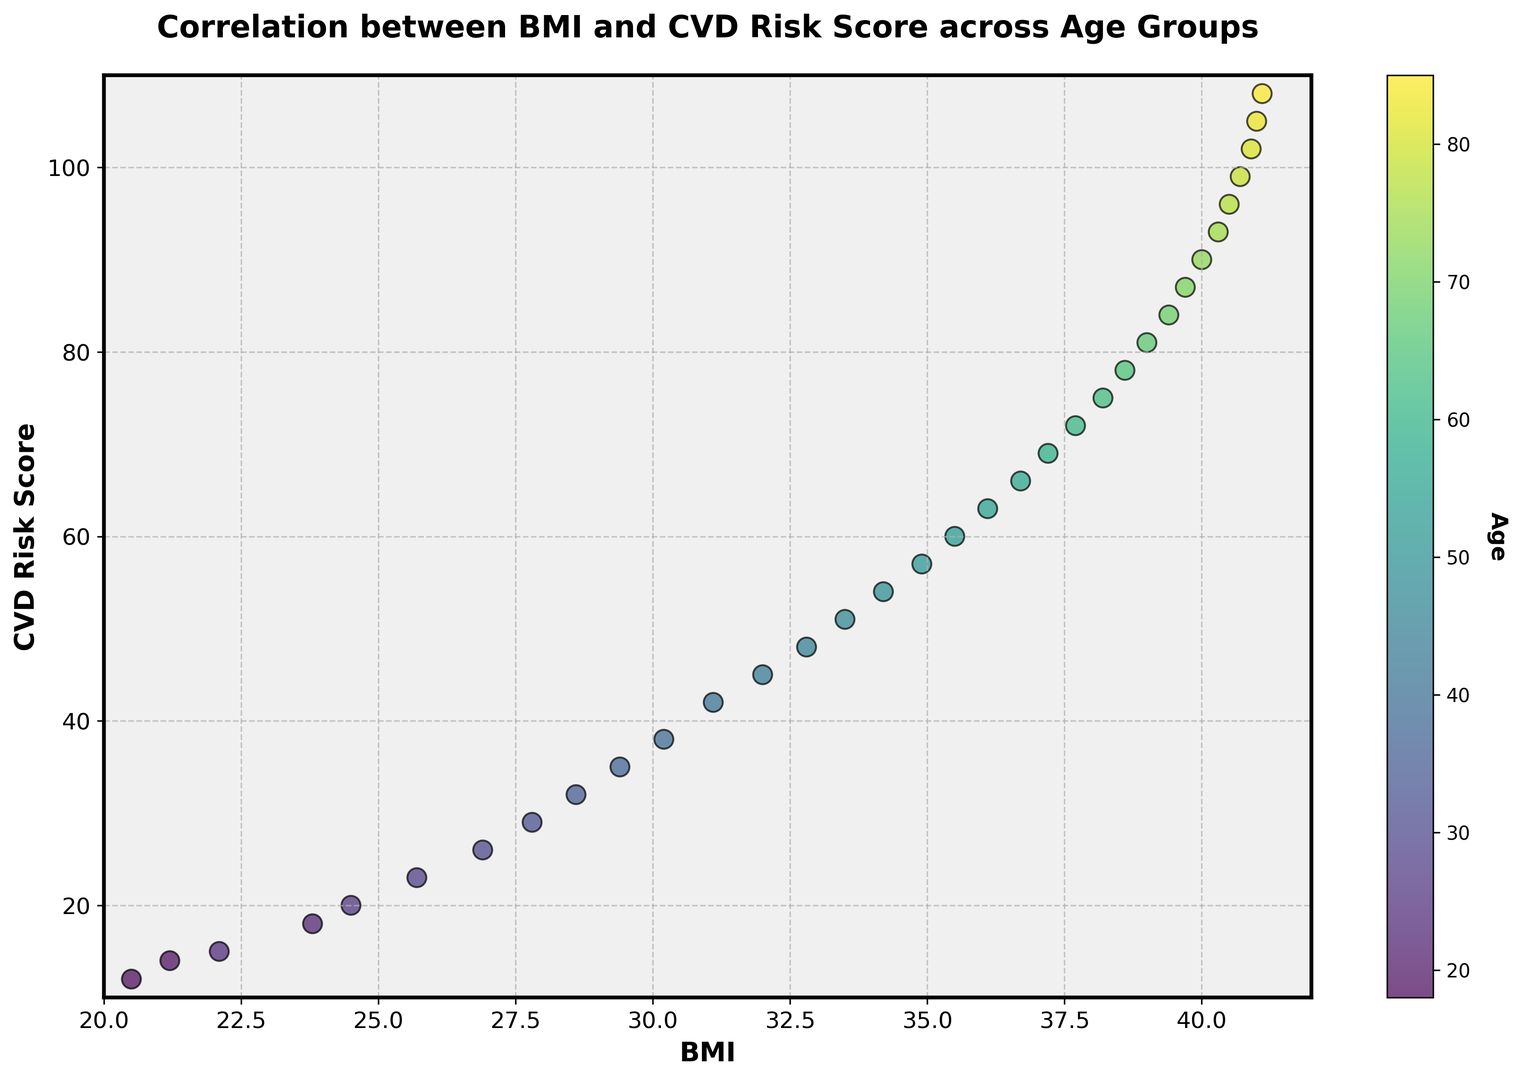What trend do you observe between BMI and CVD Risk Score for different age groups? By looking at the scatter plot, we see that as the BMI increases, the CVD Risk Score also increases. The color gradient, representing age, shows that older individuals tend to have higher BMI and CVD Risk Score, indicating a positive correlation.
Answer: Positive correlation Which age group shows the highest CVD Risk Score? In the scatter plot, the point with the highest CVD Risk Score is at the top right. The color bar shows that this corresponds to the age group at 85 years.
Answer: 85 years What is the CVD Risk Score for an individual with a BMI of approximately 34? Locate the points around a BMI of 34 on the x-axis. The approximate CVD Risk Score for these points (check the y-axis values) is around 54-57.
Answer: around 54-57 Is there any age group where the CVD Risk Score does not significantly increase with BMI? Through observation, all age groups show a clear trend: as BMI increases, the CVD Risk Score increases, leaving no noticeable exceptions.
Answer: No What is the color representing the age group with the lowest BMI? By identifying the point farthest to the left, we see it corresponds to a greenish color on the color bar, representing the age group around 18-19 years.
Answer: greenish color (18-19 years) How does the CVD Risk Score for the age group 35-45 compare to the CVD Risk Score for the age group 65-75? Comparing the colors, points corresponding to ages 35-45 (yellowish) have lower CVD Risk Scores compared to those from ages 65-75 (blueish), indicating higher risk scores in older individuals.
Answer: Lower What is the difference in CVD Risk Score between an individual with a BMI of 25 and another with a BMI of 35? Locate these BMI values on the x-axis; the corresponding CVD Risk Scores are around 22-23 and 60, respectively. The difference is 60 - 23 = 37.
Answer: 37 What can you infer about the BMI and CVD Risk Score for individuals older than 70 years? Observing the color gradient representing age over 70, individuals in this range generally have BMI above 39 and CVD Risk Scores above 90.
Answer: High BMI and high CVD Risk Score At what approximate BMI do you start to see a significant increase in CVD Risk Score? The scatter plot shows a noticeable increase in CVD Risk Score starting around a BMI of 30.
Answer: BMI of 30 Does the figure suggest that age is a factor in the correlation between BMI and CVD Risk Score? The color gradient on the scatter plot, showing older age groups having higher BMI and CVD Risk Scores, suggests age influences the correlation.
Answer: Yes 